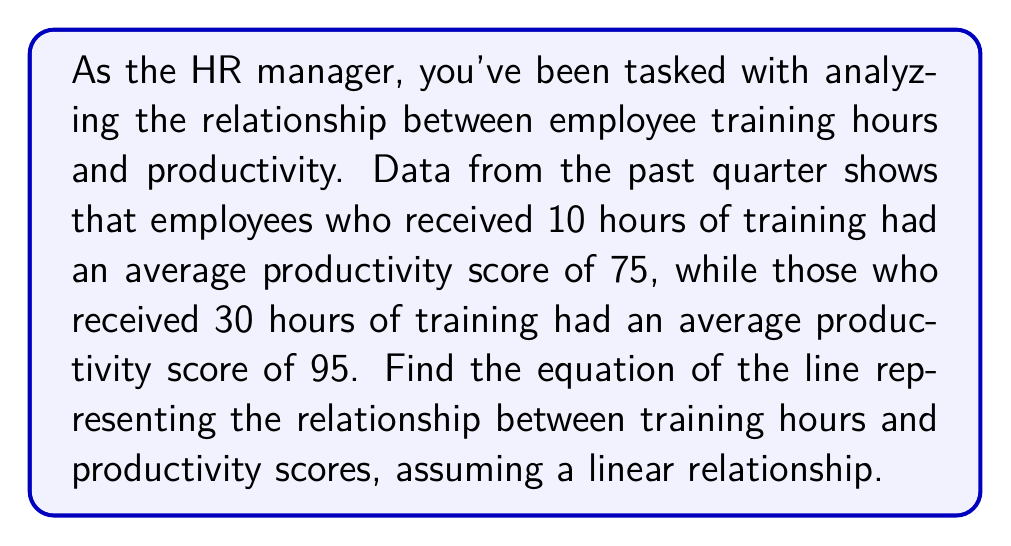Give your solution to this math problem. To find the equation of the line, we'll use the point-slope form: $y - y_1 = m(x - x_1)$, where $m$ is the slope of the line.

1. Identify the two points:
   Point 1: $(x_1, y_1) = (10, 75)$
   Point 2: $(x_2, y_2) = (30, 95)$

2. Calculate the slope $(m)$:
   $$m = \frac{y_2 - y_1}{x_2 - x_1} = \frac{95 - 75}{30 - 10} = \frac{20}{20} = 1$$

3. Use the point-slope form with $(x_1, y_1) = (10, 75)$:
   $y - 75 = 1(x - 10)$

4. Simplify the equation:
   $y - 75 = x - 10$
   $y = x - 10 + 75$
   $y = x + 65$

This equation represents the relationship between training hours $(x)$ and productivity scores $(y)$.

5. Interpret the results:
   - The slope of 1 indicates that for each additional hour of training, the productivity score increases by 1 point.
   - The y-intercept of 65 suggests that without any training, the baseline productivity score would be 65.
Answer: The equation of the line representing the relationship between training hours $(x)$ and productivity scores $(y)$ is:

$$y = x + 65$$ 